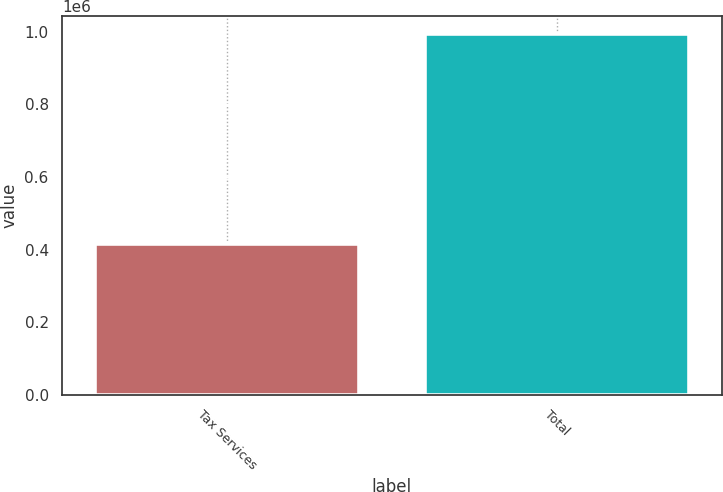Convert chart. <chart><loc_0><loc_0><loc_500><loc_500><bar_chart><fcel>Tax Services<fcel>Total<nl><fcel>415077<fcel>993919<nl></chart> 